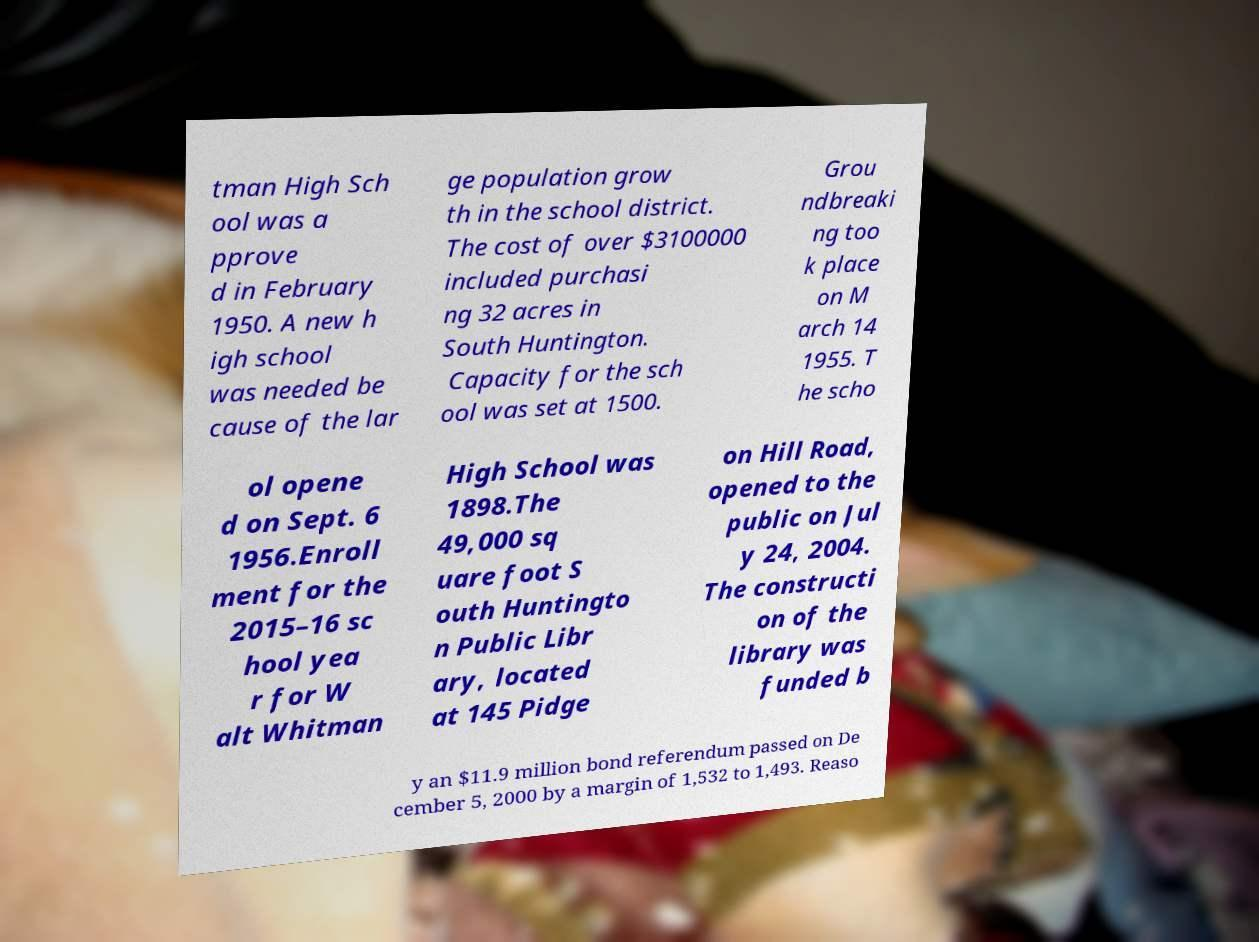Could you assist in decoding the text presented in this image and type it out clearly? tman High Sch ool was a pprove d in February 1950. A new h igh school was needed be cause of the lar ge population grow th in the school district. The cost of over $3100000 included purchasi ng 32 acres in South Huntington. Capacity for the sch ool was set at 1500. Grou ndbreaki ng too k place on M arch 14 1955. T he scho ol opene d on Sept. 6 1956.Enroll ment for the 2015–16 sc hool yea r for W alt Whitman High School was 1898.The 49,000 sq uare foot S outh Huntingto n Public Libr ary, located at 145 Pidge on Hill Road, opened to the public on Jul y 24, 2004. The constructi on of the library was funded b y an $11.9 million bond referendum passed on De cember 5, 2000 by a margin of 1,532 to 1,493. Reaso 